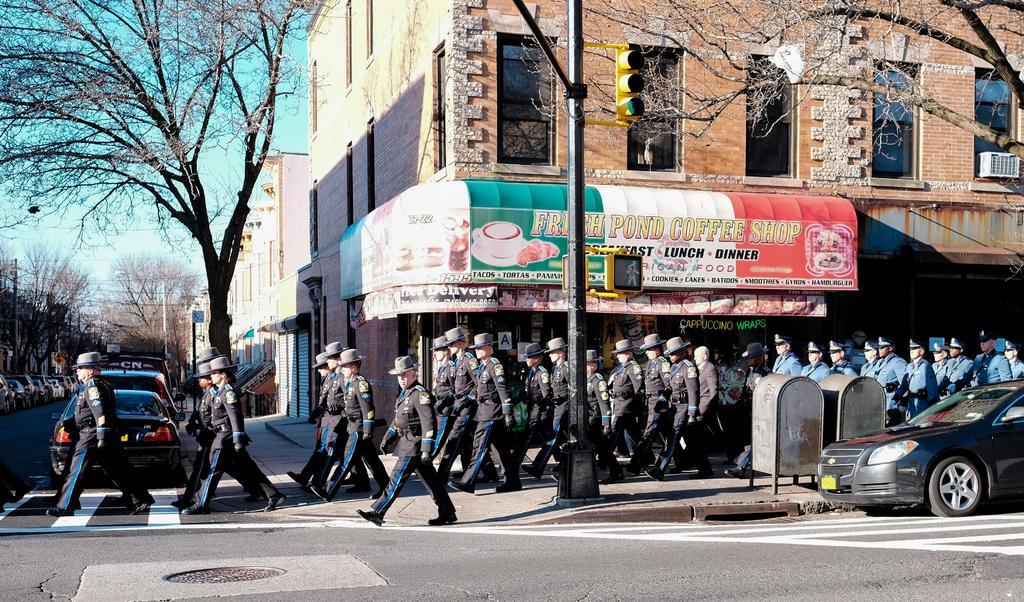Please provide a concise description of this image. In this image I can see a road in the front and on it I can see a black colour car. I can also see number of people are walking and I can see all of them are wearing uniforms and hats. In the background I can see number of trees, few poles, number of cars and the sky. I can also see a pole, few boards, signal lights in the centre and on these boards I can see something is written. On the right side of this image I can see two silver colour things and an air conditioner. 